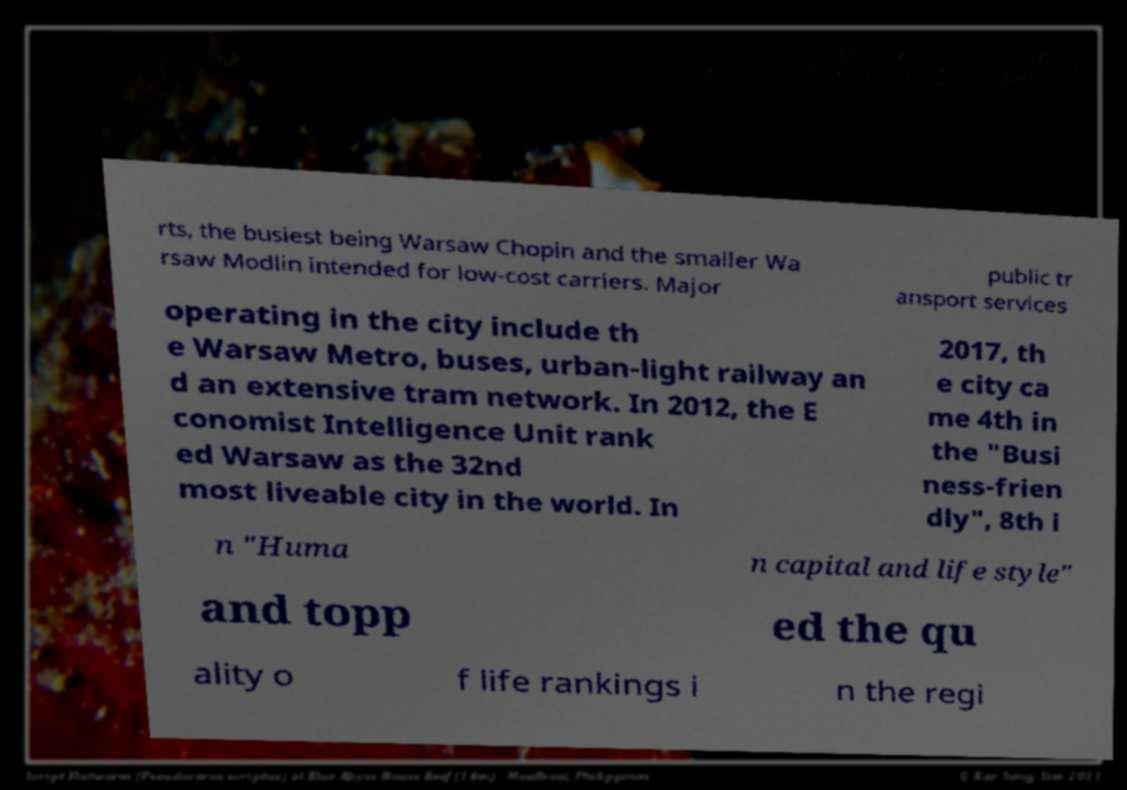Could you extract and type out the text from this image? rts, the busiest being Warsaw Chopin and the smaller Wa rsaw Modlin intended for low-cost carriers. Major public tr ansport services operating in the city include th e Warsaw Metro, buses, urban-light railway an d an extensive tram network. In 2012, the E conomist Intelligence Unit rank ed Warsaw as the 32nd most liveable city in the world. In 2017, th e city ca me 4th in the "Busi ness-frien dly", 8th i n "Huma n capital and life style" and topp ed the qu ality o f life rankings i n the regi 